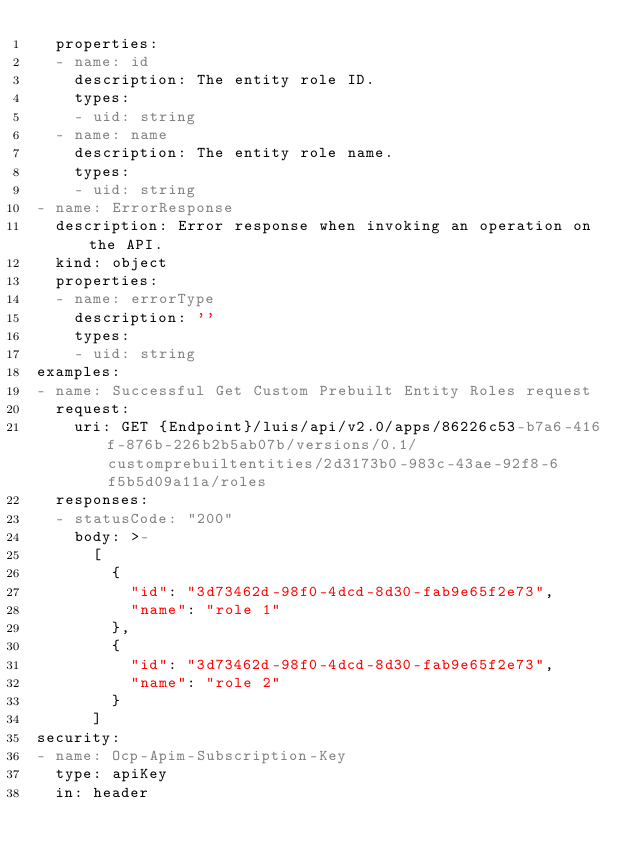Convert code to text. <code><loc_0><loc_0><loc_500><loc_500><_YAML_>  properties:
  - name: id
    description: The entity role ID.
    types:
    - uid: string
  - name: name
    description: The entity role name.
    types:
    - uid: string
- name: ErrorResponse
  description: Error response when invoking an operation on the API.
  kind: object
  properties:
  - name: errorType
    description: ''
    types:
    - uid: string
examples:
- name: Successful Get Custom Prebuilt Entity Roles request
  request:
    uri: GET {Endpoint}/luis/api/v2.0/apps/86226c53-b7a6-416f-876b-226b2b5ab07b/versions/0.1/customprebuiltentities/2d3173b0-983c-43ae-92f8-6f5b5d09a11a/roles
  responses:
  - statusCode: "200"
    body: >-
      [
        {
          "id": "3d73462d-98f0-4dcd-8d30-fab9e65f2e73",
          "name": "role 1"
        },
        {
          "id": "3d73462d-98f0-4dcd-8d30-fab9e65f2e73",
          "name": "role 2"
        }
      ]
security:
- name: Ocp-Apim-Subscription-Key
  type: apiKey
  in: header
</code> 